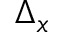<formula> <loc_0><loc_0><loc_500><loc_500>\Delta _ { x }</formula> 